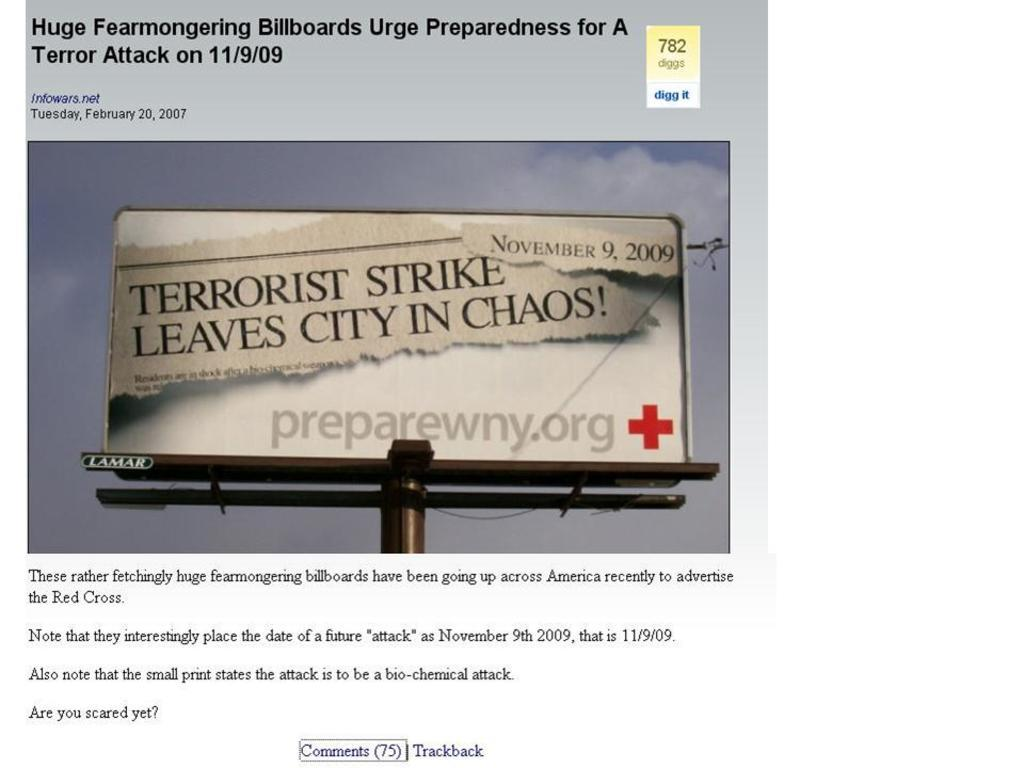<image>
Provide a brief description of the given image. A billboard that says Terrorist Strike in black and white. 